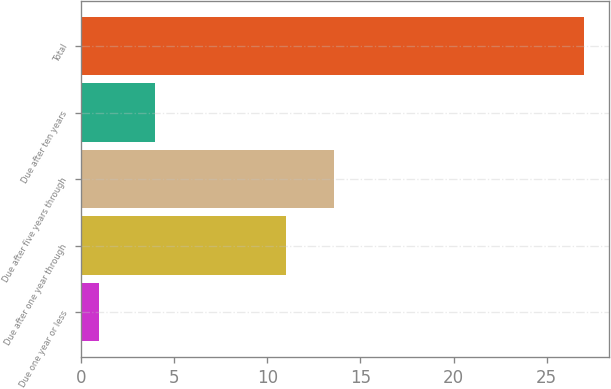Convert chart. <chart><loc_0><loc_0><loc_500><loc_500><bar_chart><fcel>Due one year or less<fcel>Due after one year through<fcel>Due after five years through<fcel>Due after ten years<fcel>Total<nl><fcel>1<fcel>11<fcel>13.6<fcel>4<fcel>27<nl></chart> 